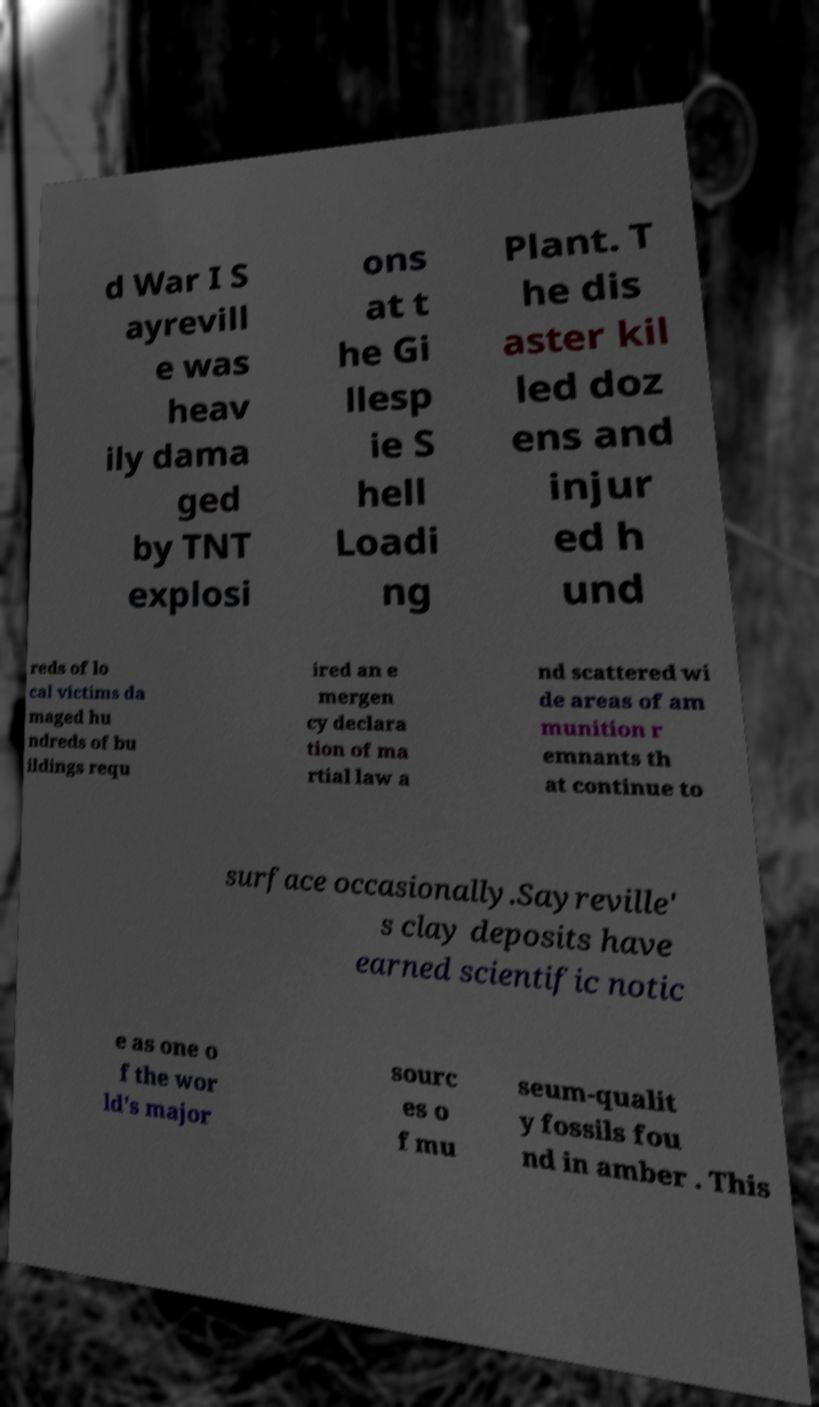Can you accurately transcribe the text from the provided image for me? d War I S ayrevill e was heav ily dama ged by TNT explosi ons at t he Gi llesp ie S hell Loadi ng Plant. T he dis aster kil led doz ens and injur ed h und reds of lo cal victims da maged hu ndreds of bu ildings requ ired an e mergen cy declara tion of ma rtial law a nd scattered wi de areas of am munition r emnants th at continue to surface occasionally.Sayreville' s clay deposits have earned scientific notic e as one o f the wor ld's major sourc es o f mu seum-qualit y fossils fou nd in amber . This 